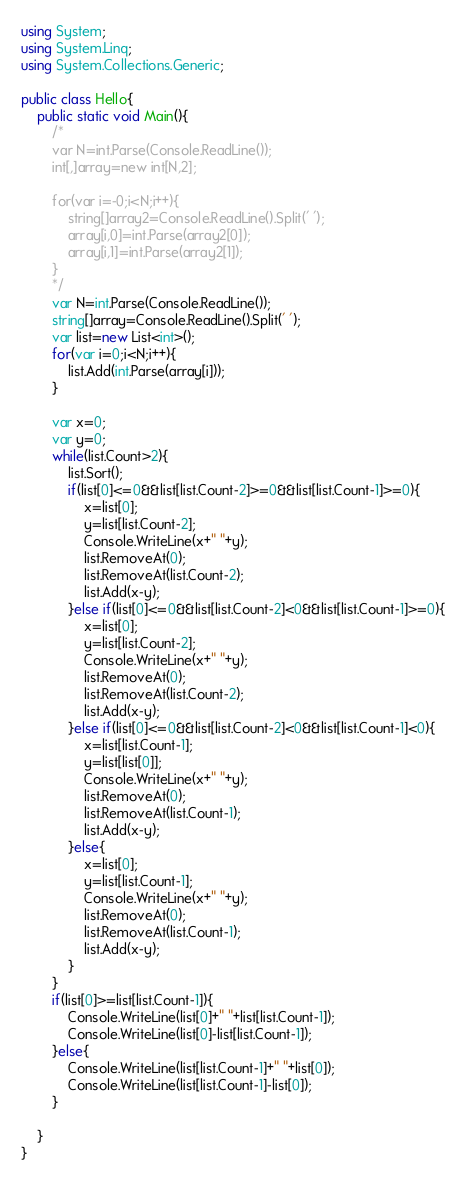Convert code to text. <code><loc_0><loc_0><loc_500><loc_500><_C#_>using System;
using System.Linq;
using System.Collections.Generic;

public class Hello{
    public static void Main(){
        /*
        var N=int.Parse(Console.ReadLine());
        int[,]array=new int[N,2];
        
        for(var i=-0;i<N;i++){
            string[]array2=Console.ReadLine().Split(' ');
            array[i,0]=int.Parse(array2[0]);
            array[i,1]=int.Parse(array2[1]);
        }
        */
        var N=int.Parse(Console.ReadLine());
        string[]array=Console.ReadLine().Split(' ');
        var list=new List<int>();
        for(var i=0;i<N;i++){
            list.Add(int.Parse(array[i]));
        }
        
        var x=0;
        var y=0;
        while(list.Count>2){
            list.Sort();
            if(list[0]<=0&&list[list.Count-2]>=0&&list[list.Count-1]>=0){
                x=list[0];
                y=list[list.Count-2];
                Console.WriteLine(x+" "+y);
                list.RemoveAt(0);
                list.RemoveAt(list.Count-2);
                list.Add(x-y);
            }else if(list[0]<=0&&list[list.Count-2]<0&&list[list.Count-1]>=0){
                x=list[0];
                y=list[list.Count-2];
                Console.WriteLine(x+" "+y);
                list.RemoveAt(0);
                list.RemoveAt(list.Count-2);
                list.Add(x-y);
            }else if(list[0]<=0&&list[list.Count-2]<0&&list[list.Count-1]<0){
                x=list[list.Count-1];
                y=list[list[0]];
                Console.WriteLine(x+" "+y);
                list.RemoveAt(0);
                list.RemoveAt(list.Count-1);
                list.Add(x-y);
            }else{
                x=list[0];
                y=list[list.Count-1];
                Console.WriteLine(x+" "+y);
                list.RemoveAt(0);
                list.RemoveAt(list.Count-1);
                list.Add(x-y);
            }
        }
        if(list[0]>=list[list.Count-1]){
            Console.WriteLine(list[0]+" "+list[list.Count-1]);
            Console.WriteLine(list[0]-list[list.Count-1]);
        }else{
            Console.WriteLine(list[list.Count-1]+" "+list[0]);
            Console.WriteLine(list[list.Count-1]-list[0]);
        }
        
    }
}
</code> 